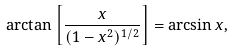<formula> <loc_0><loc_0><loc_500><loc_500>\arctan \left [ \frac { x } { ( 1 - x ^ { 2 } ) ^ { 1 / 2 } } \right ] = \arcsin x ,</formula> 